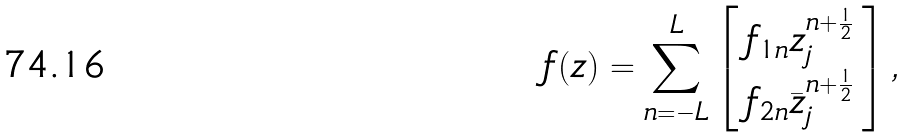<formula> <loc_0><loc_0><loc_500><loc_500>f ( z ) = \sum _ { n = - L } ^ { L } \left [ \begin{array} { c } f _ { 1 n } z ^ { n + \frac { 1 } { 2 } } _ { j } \\ f _ { 2 n } \bar { z } ^ { n + \frac { 1 } { 2 } } _ { j } \end{array} \right ] ,</formula> 